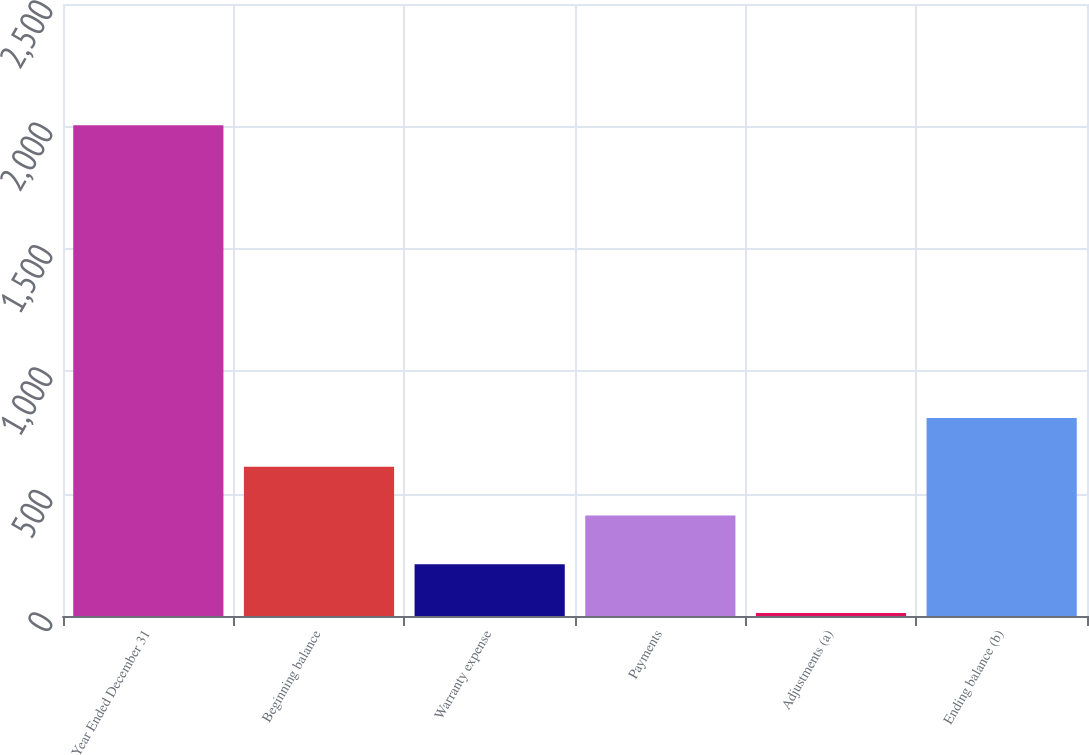<chart> <loc_0><loc_0><loc_500><loc_500><bar_chart><fcel>Year Ended December 31<fcel>Beginning balance<fcel>Warranty expense<fcel>Payments<fcel>Adjustments (a)<fcel>Ending balance (b)<nl><fcel>2005<fcel>609.9<fcel>211.3<fcel>410.6<fcel>12<fcel>809.2<nl></chart> 